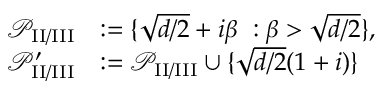Convert formula to latex. <formula><loc_0><loc_0><loc_500><loc_500>\begin{array} { r l } { { { \mathcal { P } } } _ { I I / I I I } } & { \colon = \{ \sqrt { d / 2 } + i \beta \ \colon \beta > \sqrt { d / 2 } \} , } \\ { { { \mathcal { P } } } _ { I I / I I I } ^ { \prime } } & { \colon = { { \mathcal { P } } } _ { I I / I I I } \cup \{ \sqrt { d / 2 } ( 1 + i ) \} } \end{array}</formula> 